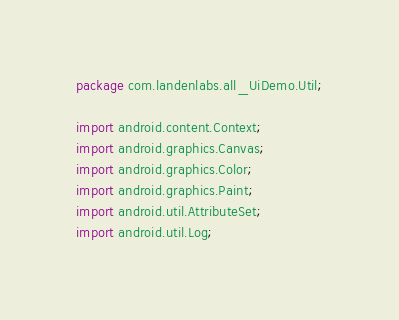<code> <loc_0><loc_0><loc_500><loc_500><_Java_>package com.landenlabs.all_UiDemo.Util;

import android.content.Context;
import android.graphics.Canvas;
import android.graphics.Color;
import android.graphics.Paint;
import android.util.AttributeSet;
import android.util.Log;</code> 